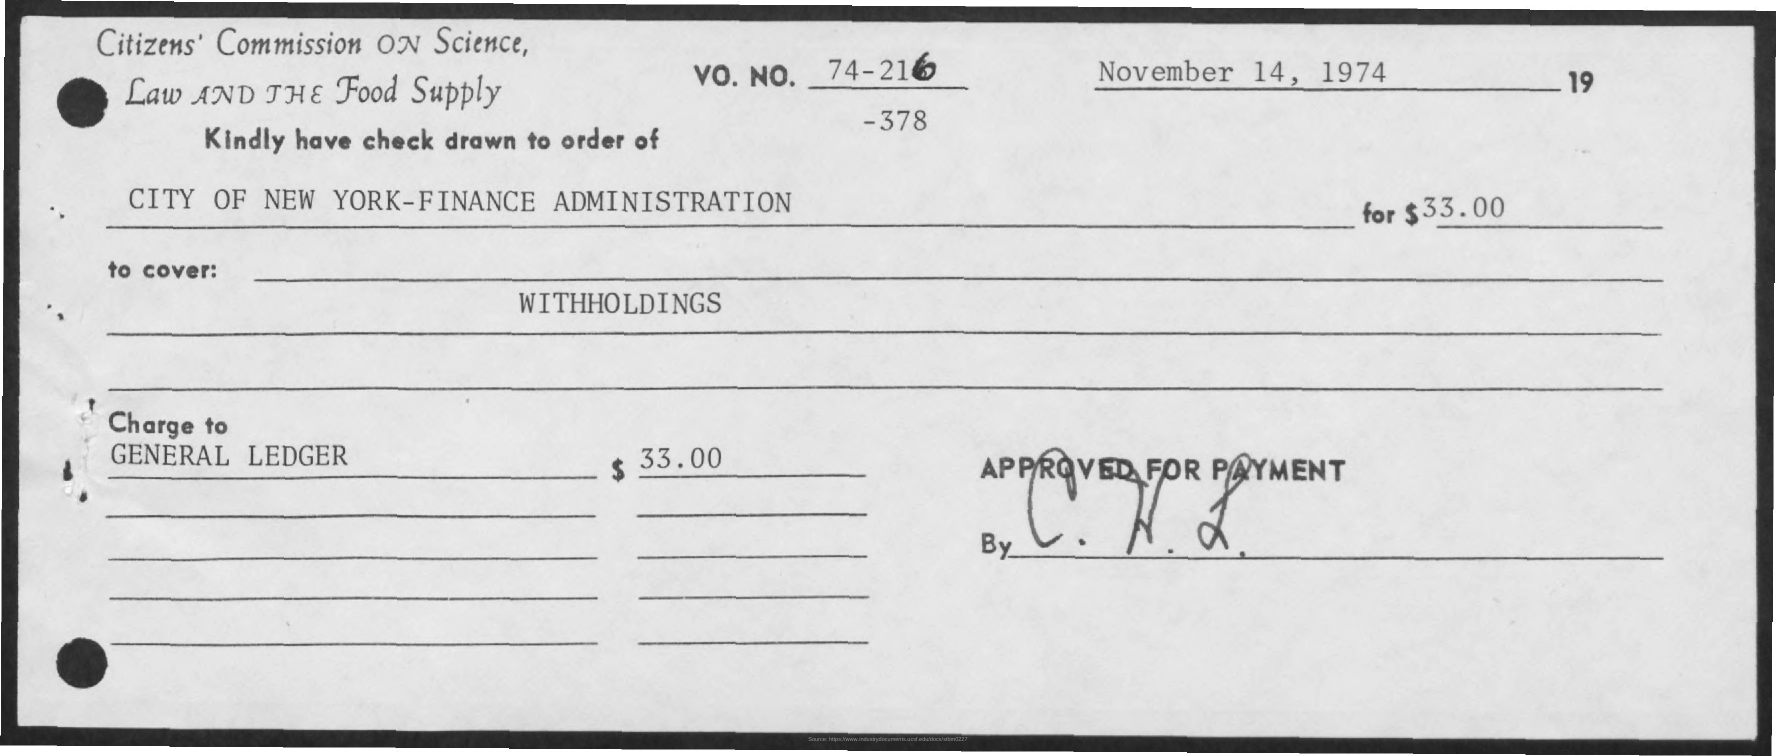Specify some key components in this picture. The City of New York's Finance Administration is the drawer of the cheque. The cheque was written for a total of 33.00 dollars, as indicated by the decimal point notation. 